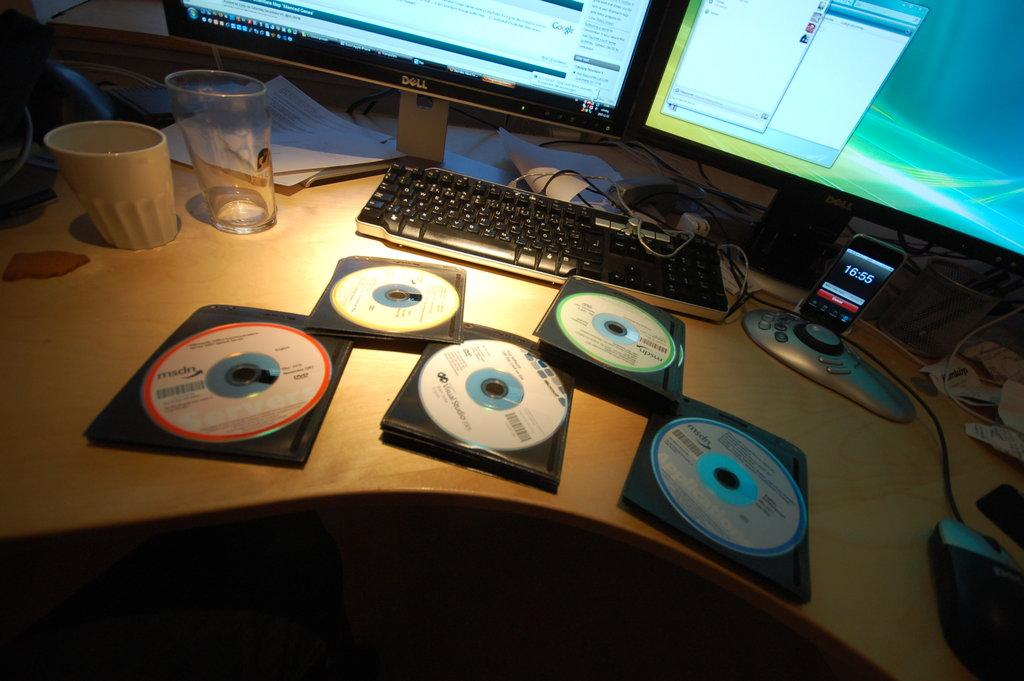What type of electronic device is visible in the image? There is a monitor in the image. What input device is present in the image? There is a keyboard and a mouse in the image. What gaming device is visible in the image? There is a joystick in the image. What type of communication device is present in the image? There is a mobile in the image. What type of storage media is present in the image? There are compact discs in the image. What type of beverage container is present in the image? There is a glass and a cup in the image. What type of paper-based items are present in the image? There are papers in the image. What type of sock is visible in the image? There is no sock present in the image. What is the fifth item on the list of items in the image? The list of items provided does not have a fifth item, as it only has nine items. 